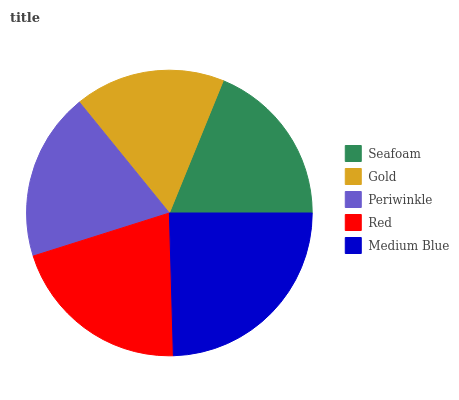Is Gold the minimum?
Answer yes or no. Yes. Is Medium Blue the maximum?
Answer yes or no. Yes. Is Periwinkle the minimum?
Answer yes or no. No. Is Periwinkle the maximum?
Answer yes or no. No. Is Periwinkle greater than Gold?
Answer yes or no. Yes. Is Gold less than Periwinkle?
Answer yes or no. Yes. Is Gold greater than Periwinkle?
Answer yes or no. No. Is Periwinkle less than Gold?
Answer yes or no. No. Is Periwinkle the high median?
Answer yes or no. Yes. Is Periwinkle the low median?
Answer yes or no. Yes. Is Gold the high median?
Answer yes or no. No. Is Red the low median?
Answer yes or no. No. 